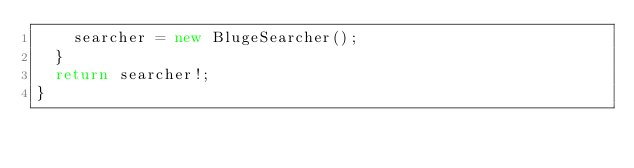Convert code to text. <code><loc_0><loc_0><loc_500><loc_500><_TypeScript_>    searcher = new BlugeSearcher();
  }
  return searcher!;
}
</code> 